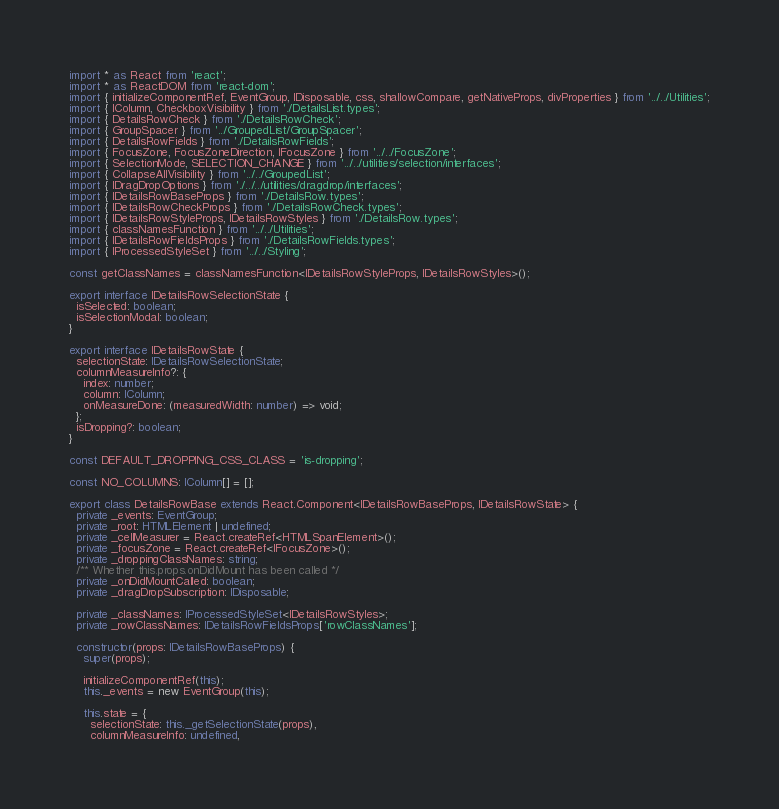<code> <loc_0><loc_0><loc_500><loc_500><_TypeScript_>import * as React from 'react';
import * as ReactDOM from 'react-dom';
import { initializeComponentRef, EventGroup, IDisposable, css, shallowCompare, getNativeProps, divProperties } from '../../Utilities';
import { IColumn, CheckboxVisibility } from './DetailsList.types';
import { DetailsRowCheck } from './DetailsRowCheck';
import { GroupSpacer } from '../GroupedList/GroupSpacer';
import { DetailsRowFields } from './DetailsRowFields';
import { FocusZone, FocusZoneDirection, IFocusZone } from '../../FocusZone';
import { SelectionMode, SELECTION_CHANGE } from '../../utilities/selection/interfaces';
import { CollapseAllVisibility } from '../../GroupedList';
import { IDragDropOptions } from './../../utilities/dragdrop/interfaces';
import { IDetailsRowBaseProps } from './DetailsRow.types';
import { IDetailsRowCheckProps } from './DetailsRowCheck.types';
import { IDetailsRowStyleProps, IDetailsRowStyles } from './DetailsRow.types';
import { classNamesFunction } from '../../Utilities';
import { IDetailsRowFieldsProps } from './DetailsRowFields.types';
import { IProcessedStyleSet } from '../../Styling';

const getClassNames = classNamesFunction<IDetailsRowStyleProps, IDetailsRowStyles>();

export interface IDetailsRowSelectionState {
  isSelected: boolean;
  isSelectionModal: boolean;
}

export interface IDetailsRowState {
  selectionState: IDetailsRowSelectionState;
  columnMeasureInfo?: {
    index: number;
    column: IColumn;
    onMeasureDone: (measuredWidth: number) => void;
  };
  isDropping?: boolean;
}

const DEFAULT_DROPPING_CSS_CLASS = 'is-dropping';

const NO_COLUMNS: IColumn[] = [];

export class DetailsRowBase extends React.Component<IDetailsRowBaseProps, IDetailsRowState> {
  private _events: EventGroup;
  private _root: HTMLElement | undefined;
  private _cellMeasurer = React.createRef<HTMLSpanElement>();
  private _focusZone = React.createRef<IFocusZone>();
  private _droppingClassNames: string;
  /** Whether this.props.onDidMount has been called */
  private _onDidMountCalled: boolean;
  private _dragDropSubscription: IDisposable;

  private _classNames: IProcessedStyleSet<IDetailsRowStyles>;
  private _rowClassNames: IDetailsRowFieldsProps['rowClassNames'];

  constructor(props: IDetailsRowBaseProps) {
    super(props);

    initializeComponentRef(this);
    this._events = new EventGroup(this);

    this.state = {
      selectionState: this._getSelectionState(props),
      columnMeasureInfo: undefined,</code> 